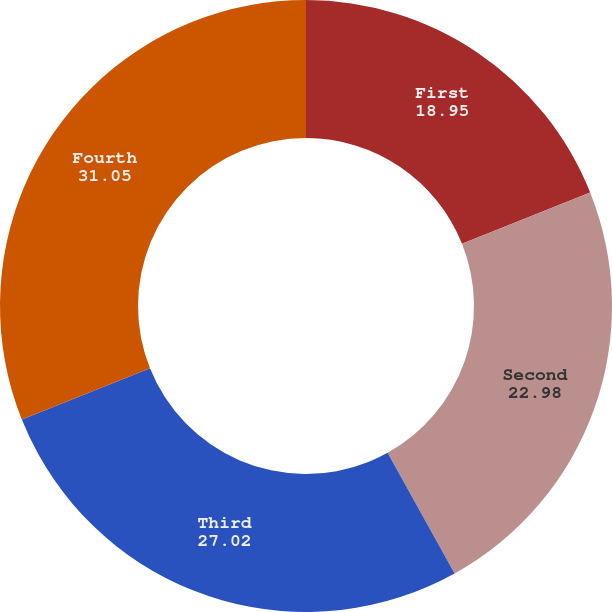<chart> <loc_0><loc_0><loc_500><loc_500><pie_chart><fcel>First<fcel>Second<fcel>Third<fcel>Fourth<nl><fcel>18.95%<fcel>22.98%<fcel>27.02%<fcel>31.05%<nl></chart> 